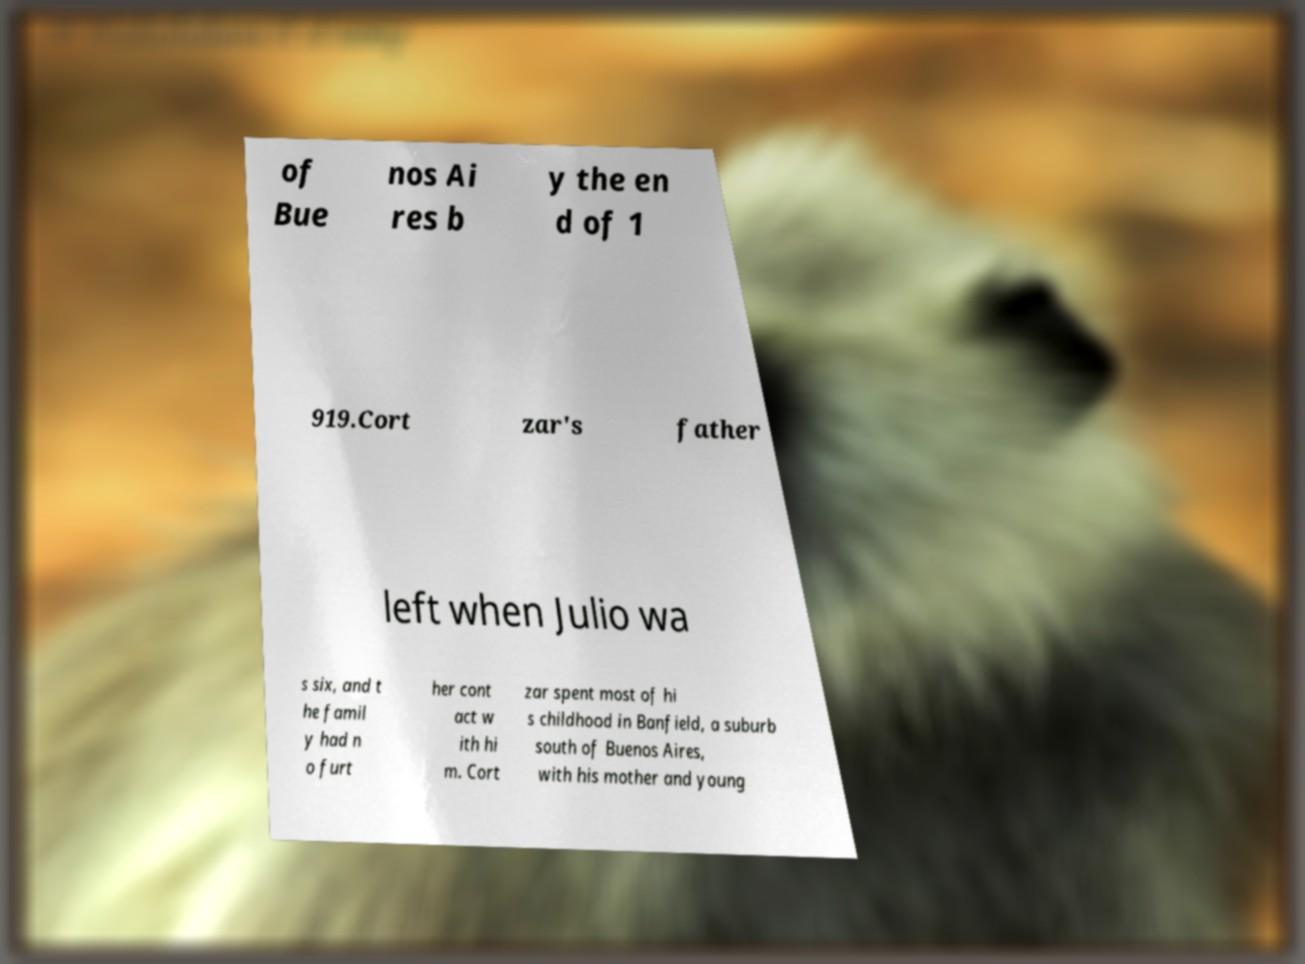I need the written content from this picture converted into text. Can you do that? of Bue nos Ai res b y the en d of 1 919.Cort zar's father left when Julio wa s six, and t he famil y had n o furt her cont act w ith hi m. Cort zar spent most of hi s childhood in Banfield, a suburb south of Buenos Aires, with his mother and young 